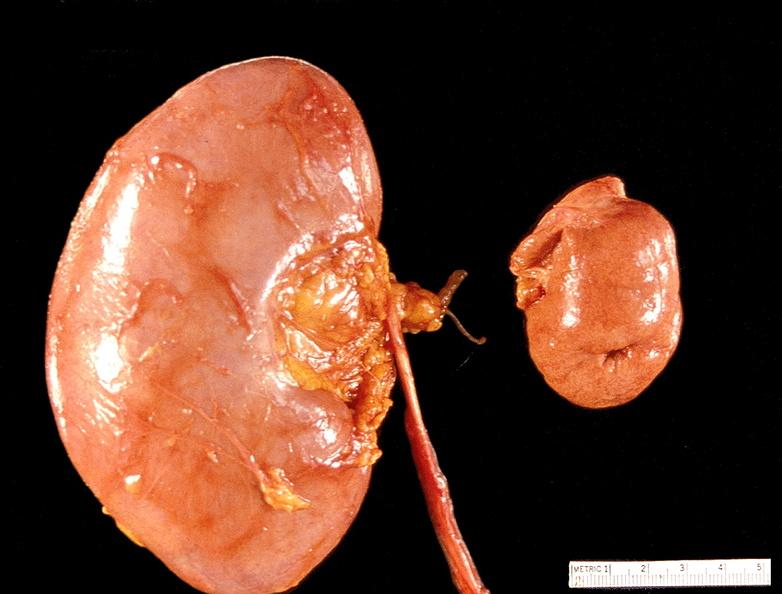does this image show kidney, hypoplasia and compensatory hypertrophy 300 grams left?
Answer the question using a single word or phrase. Yes 